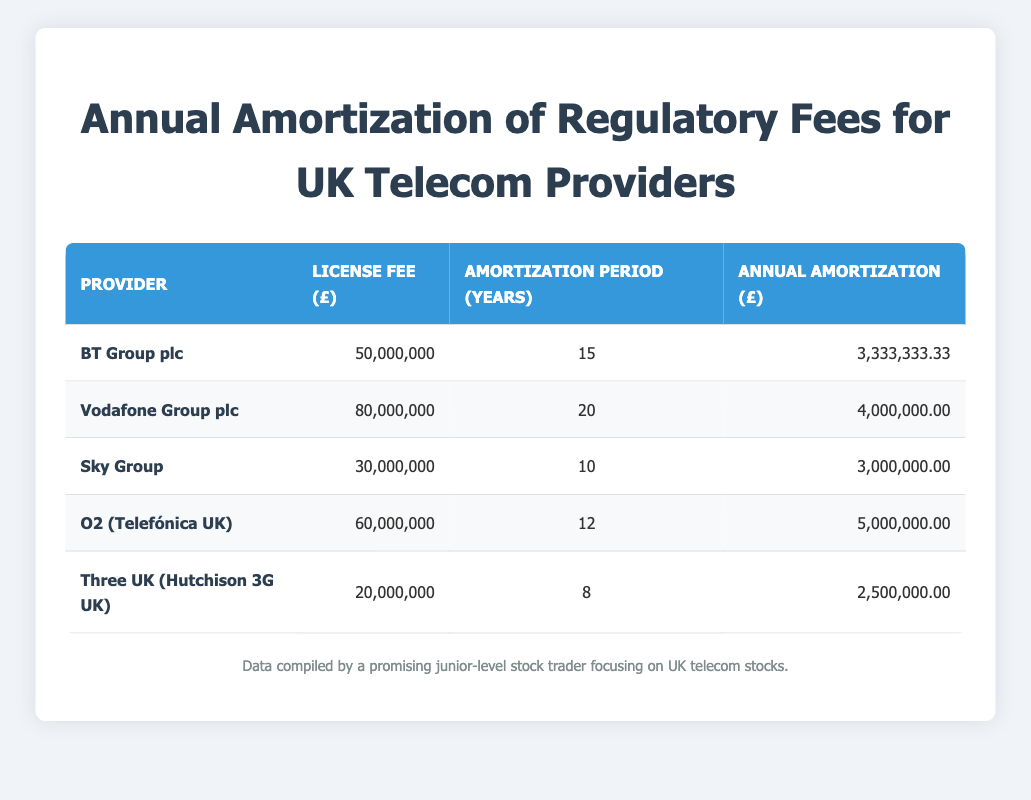What is the annual amortization for BT Group plc? The table shows that the annual amortization for BT Group plc is listed in the corresponding row under the "Annual Amortization (£)" column. The value is 3,333,333.33.
Answer: 3,333,333.33 How long is the amortization period for Vodafone Group plc? Looking at the table, the amortization period for Vodafone Group plc can be found under the "Amortization Period (Years)" column, which shows a value of 20 years.
Answer: 20 years Which provider has the lowest annual amortization? To determine which provider has the lowest annual amortization, we need to compare the values in the "Annual Amortization (£)" column. The lowest value is for Three UK, which is 2,500,000.00.
Answer: Three UK (Hutchison 3G UK) What is the total license fee for all providers combined? To find the total license fee, we sum the values from the "License Fee (£)" column: 50,000,000 + 80,000,000 + 30,000,000 + 60,000,000 + 20,000,000 = 240,000,000.
Answer: 240,000,000 Is the annual amortization for O2 (Telefónica UK) greater than that of Sky Group? By checking both corresponding values in the "Annual Amortization (£)" column, we see O2 has 5,000,000.00 and Sky has 3,000,000.00. Since 5,000,000.00 is greater than 3,000,000.00, the answer is yes.
Answer: Yes What is the average annual amortization across all providers? To find the average, we add the annual amortization for all providers: 3,333,333.33 + 4,000,000 + 3,000,000 + 5,000,000 + 2,500,000 = 17,833,333.33. Next, we divide this sum by the number of providers (5): 17,833,333.33 / 5 = 3,566,666.67.
Answer: 3,566,666.67 How many providers have an amortization period of more than 15 years? We will check the "Amortization Period (Years)" column for values greater than 15. The providers with such periods are Vodafone (20 years) and O2 (Telefónica UK) (12 years); therefore, there is only one provider: Vodafone Group plc.
Answer: 1 Is there any provider with a license fee over 70 million? We look at the "License Fee (£)" column to find any values exceeding 70 million. Only Vodafone Group plc has a fee of 80,000,000. Thus, the answer is yes.
Answer: Yes What is the difference in annual amortization between BT Group plc and O2 (Telefónica UK)? We find the annual amortization for both in the "Annual Amortization (£)" column: BT Group plc has 3,333,333.33 and O2 has 5,000,000.00. The difference is calculated by subtracting BT's value from O2's: 5,000,000.00 - 3,333,333.33 = 1,666,666.67.
Answer: 1,666,666.67 